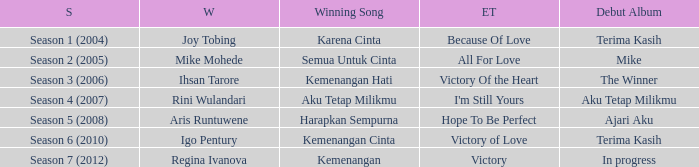Which album debuted in season 2 (2005)? Mike. 